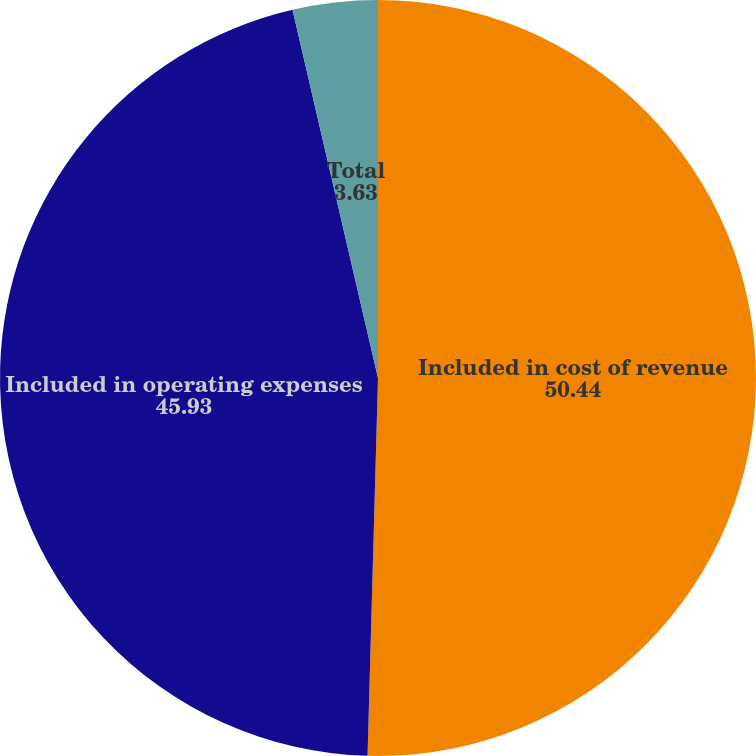<chart> <loc_0><loc_0><loc_500><loc_500><pie_chart><fcel>Included in cost of revenue<fcel>Included in operating expenses<fcel>Total<nl><fcel>50.44%<fcel>45.93%<fcel>3.63%<nl></chart> 